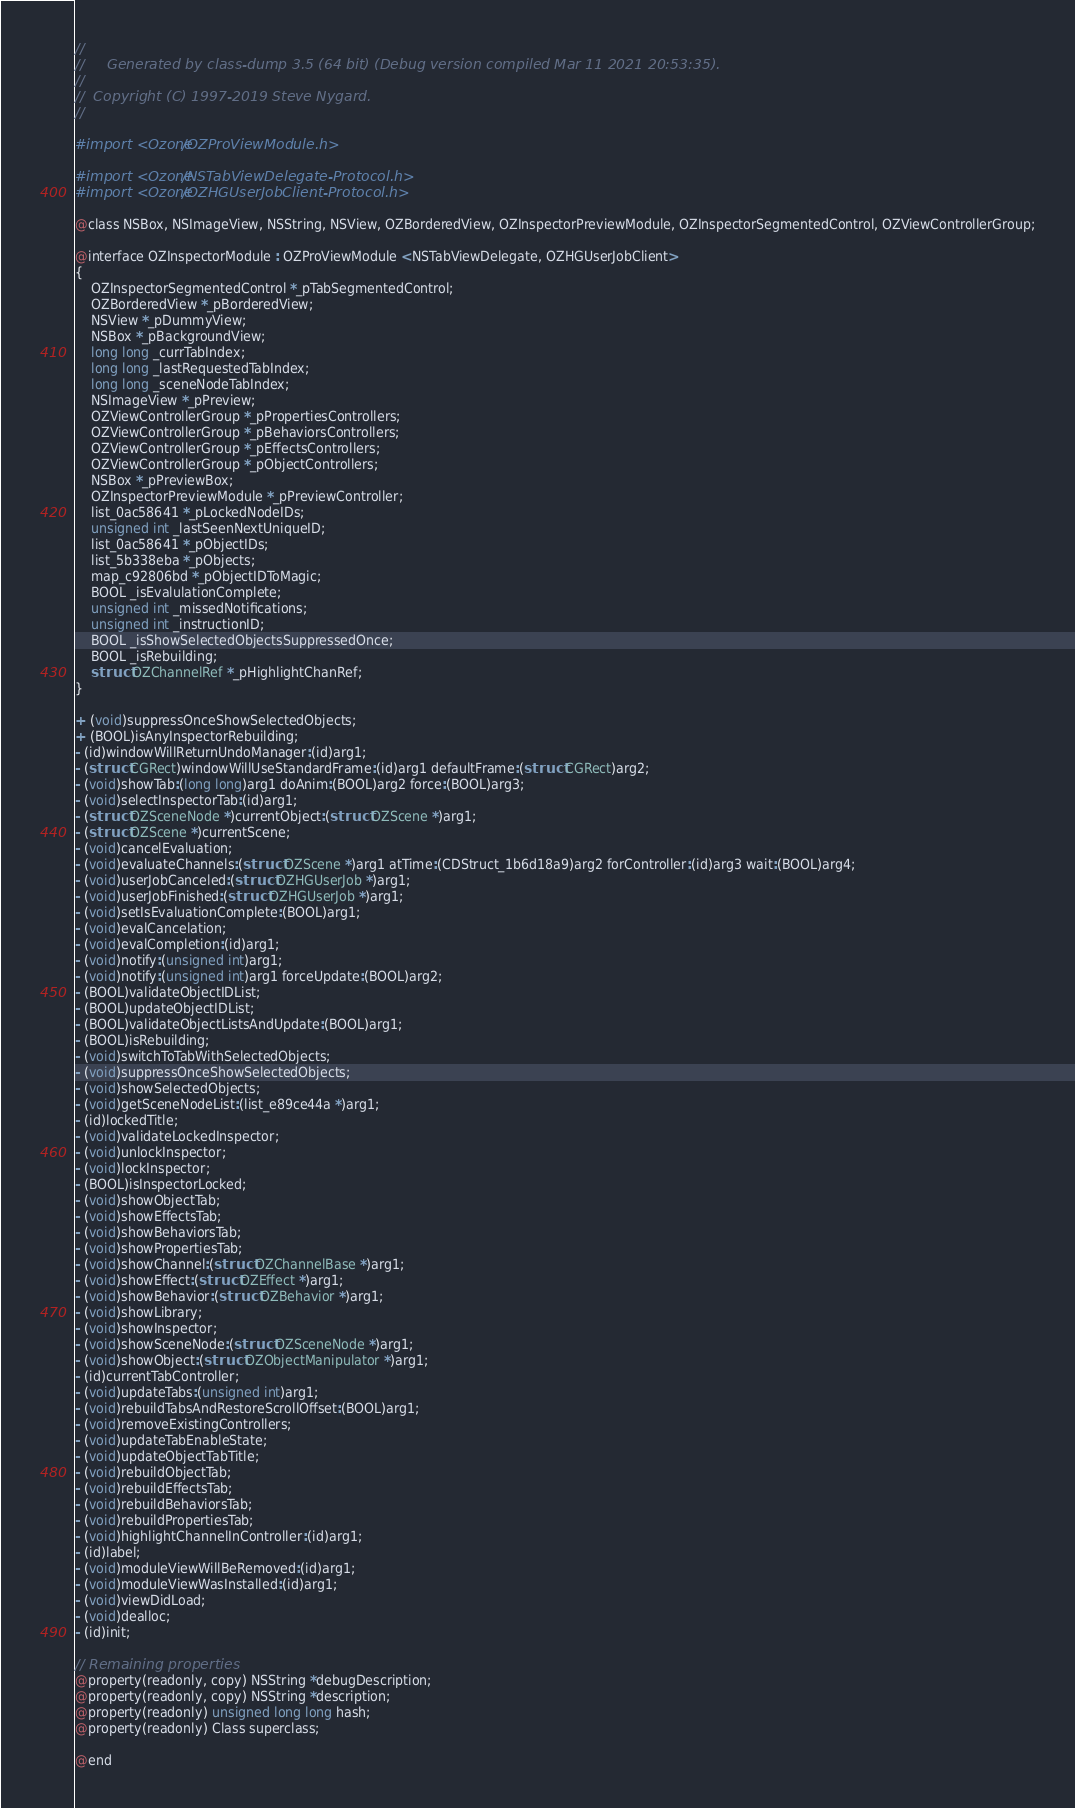Convert code to text. <code><loc_0><loc_0><loc_500><loc_500><_C_>//
//     Generated by class-dump 3.5 (64 bit) (Debug version compiled Mar 11 2021 20:53:35).
//
//  Copyright (C) 1997-2019 Steve Nygard.
//

#import <Ozone/OZProViewModule.h>

#import <Ozone/NSTabViewDelegate-Protocol.h>
#import <Ozone/OZHGUserJobClient-Protocol.h>

@class NSBox, NSImageView, NSString, NSView, OZBorderedView, OZInspectorPreviewModule, OZInspectorSegmentedControl, OZViewControllerGroup;

@interface OZInspectorModule : OZProViewModule <NSTabViewDelegate, OZHGUserJobClient>
{
    OZInspectorSegmentedControl *_pTabSegmentedControl;
    OZBorderedView *_pBorderedView;
    NSView *_pDummyView;
    NSBox *_pBackgroundView;
    long long _currTabIndex;
    long long _lastRequestedTabIndex;
    long long _sceneNodeTabIndex;
    NSImageView *_pPreview;
    OZViewControllerGroup *_pPropertiesControllers;
    OZViewControllerGroup *_pBehaviorsControllers;
    OZViewControllerGroup *_pEffectsControllers;
    OZViewControllerGroup *_pObjectControllers;
    NSBox *_pPreviewBox;
    OZInspectorPreviewModule *_pPreviewController;
    list_0ac58641 *_pLockedNodeIDs;
    unsigned int _lastSeenNextUniqueID;
    list_0ac58641 *_pObjectIDs;
    list_5b338eba *_pObjects;
    map_c92806bd *_pObjectIDToMagic;
    BOOL _isEvalulationComplete;
    unsigned int _missedNotifications;
    unsigned int _instructionID;
    BOOL _isShowSelectedObjectsSuppressedOnce;
    BOOL _isRebuilding;
    struct OZChannelRef *_pHighlightChanRef;
}

+ (void)suppressOnceShowSelectedObjects;
+ (BOOL)isAnyInspectorRebuilding;
- (id)windowWillReturnUndoManager:(id)arg1;
- (struct CGRect)windowWillUseStandardFrame:(id)arg1 defaultFrame:(struct CGRect)arg2;
- (void)showTab:(long long)arg1 doAnim:(BOOL)arg2 force:(BOOL)arg3;
- (void)selectInspectorTab:(id)arg1;
- (struct OZSceneNode *)currentObject:(struct OZScene *)arg1;
- (struct OZScene *)currentScene;
- (void)cancelEvaluation;
- (void)evaluateChannels:(struct OZScene *)arg1 atTime:(CDStruct_1b6d18a9)arg2 forController:(id)arg3 wait:(BOOL)arg4;
- (void)userJobCanceled:(struct OZHGUserJob *)arg1;
- (void)userJobFinished:(struct OZHGUserJob *)arg1;
- (void)setIsEvaluationComplete:(BOOL)arg1;
- (void)evalCancelation;
- (void)evalCompletion:(id)arg1;
- (void)notify:(unsigned int)arg1;
- (void)notify:(unsigned int)arg1 forceUpdate:(BOOL)arg2;
- (BOOL)validateObjectIDList;
- (BOOL)updateObjectIDList;
- (BOOL)validateObjectListsAndUpdate:(BOOL)arg1;
- (BOOL)isRebuilding;
- (void)switchToTabWithSelectedObjects;
- (void)suppressOnceShowSelectedObjects;
- (void)showSelectedObjects;
- (void)getSceneNodeList:(list_e89ce44a *)arg1;
- (id)lockedTitle;
- (void)validateLockedInspector;
- (void)unlockInspector;
- (void)lockInspector;
- (BOOL)isInspectorLocked;
- (void)showObjectTab;
- (void)showEffectsTab;
- (void)showBehaviorsTab;
- (void)showPropertiesTab;
- (void)showChannel:(struct OZChannelBase *)arg1;
- (void)showEffect:(struct OZEffect *)arg1;
- (void)showBehavior:(struct OZBehavior *)arg1;
- (void)showLibrary;
- (void)showInspector;
- (void)showSceneNode:(struct OZSceneNode *)arg1;
- (void)showObject:(struct OZObjectManipulator *)arg1;
- (id)currentTabController;
- (void)updateTabs:(unsigned int)arg1;
- (void)rebuildTabsAndRestoreScrollOffset:(BOOL)arg1;
- (void)removeExistingControllers;
- (void)updateTabEnableState;
- (void)updateObjectTabTitle;
- (void)rebuildObjectTab;
- (void)rebuildEffectsTab;
- (void)rebuildBehaviorsTab;
- (void)rebuildPropertiesTab;
- (void)highlightChannelInController:(id)arg1;
- (id)label;
- (void)moduleViewWillBeRemoved:(id)arg1;
- (void)moduleViewWasInstalled:(id)arg1;
- (void)viewDidLoad;
- (void)dealloc;
- (id)init;

// Remaining properties
@property(readonly, copy) NSString *debugDescription;
@property(readonly, copy) NSString *description;
@property(readonly) unsigned long long hash;
@property(readonly) Class superclass;

@end

</code> 